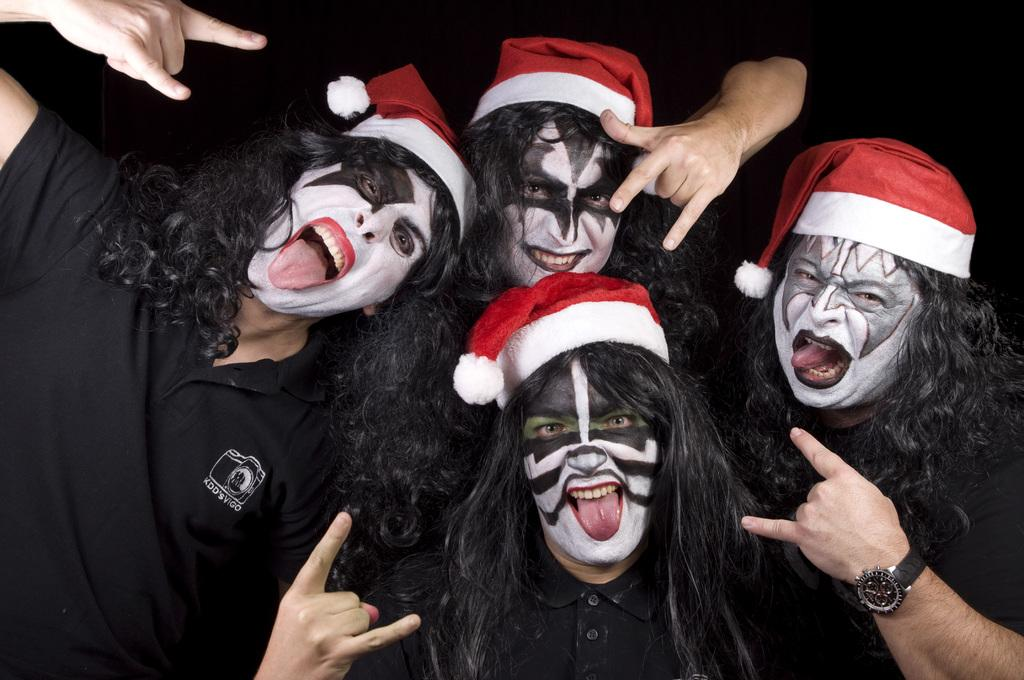Who or what can be seen in the image? There are people in the image. What are the people wearing? The people are wearing different costumes. What can be observed about the background of the image? The background of the image is dark. What type of pear can be seen hanging from the bells in the image? There is no pear or bells present in the image. What instrument is being played by the people in the image? The provided facts do not mention any instruments being played by the people in the image. 